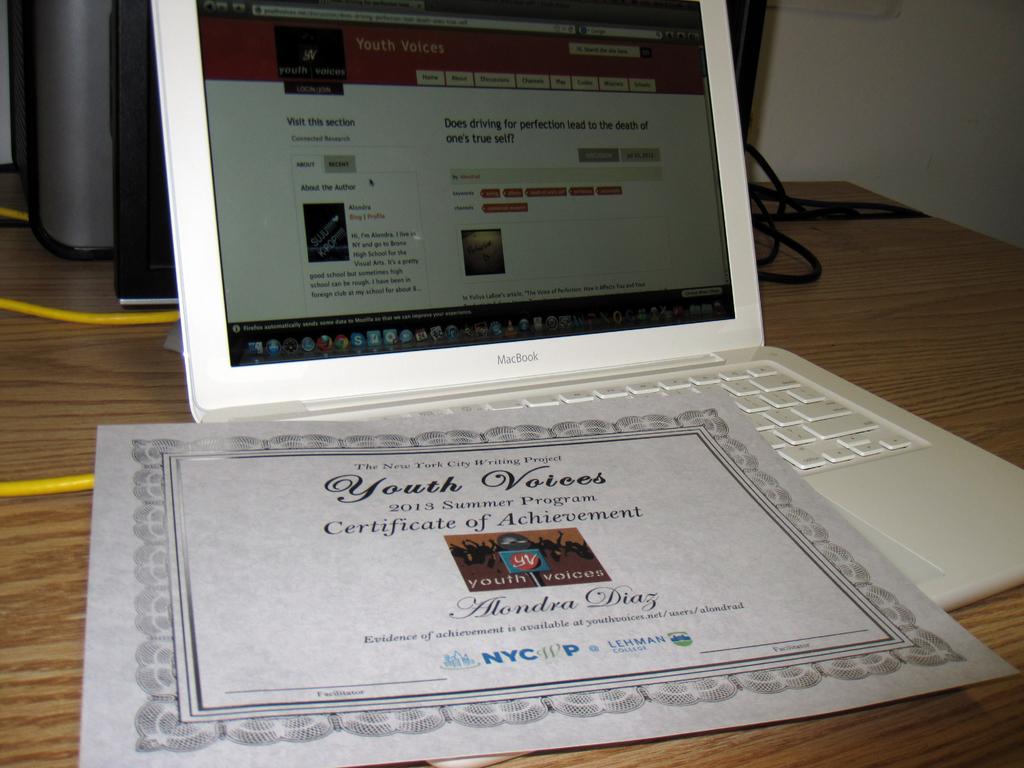What sort of certificate?
Your answer should be compact. Achievement. Who was the certificate awarded to?
Offer a terse response. Alondra diaz. 